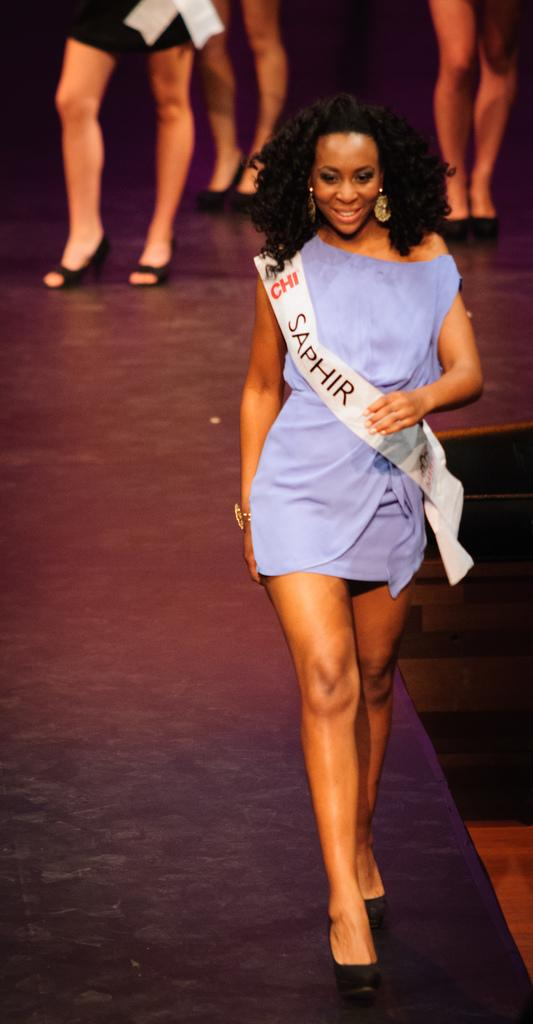<image>
Share a concise interpretation of the image provided. A woman in a blue dress is wearing a sash that says SAPHIR on it. 